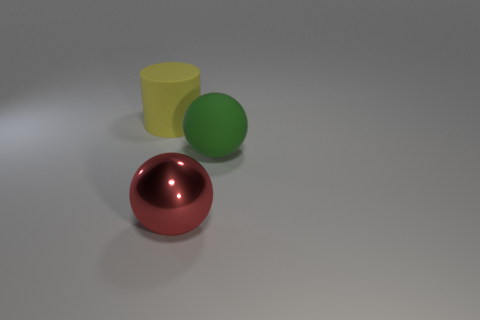Add 2 brown rubber blocks. How many objects exist? 5 Subtract all gray cubes. How many green balls are left? 1 Subtract all green rubber spheres. Subtract all big green balls. How many objects are left? 1 Add 3 yellow rubber things. How many yellow rubber things are left? 4 Add 3 large yellow objects. How many large yellow objects exist? 4 Subtract 0 blue blocks. How many objects are left? 3 Subtract all cylinders. How many objects are left? 2 Subtract all yellow spheres. Subtract all brown cubes. How many spheres are left? 2 